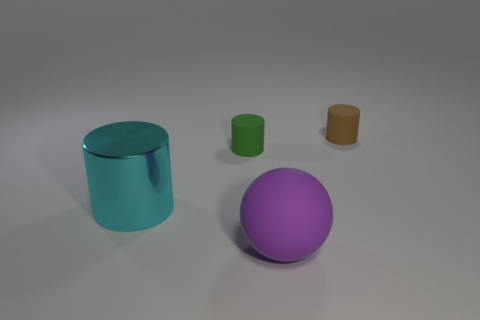Is the number of purple balls in front of the cyan cylinder greater than the number of tiny cyan metallic cubes?
Your response must be concise. Yes. What is the material of the thing that is to the right of the big cyan thing and left of the purple object?
Provide a succinct answer. Rubber. Is there any other thing that has the same shape as the small green thing?
Offer a very short reply. Yes. What number of objects are left of the small brown matte cylinder and on the right side of the cyan shiny cylinder?
Offer a terse response. 2. Are there an equal number of tiny green matte spheres and big purple rubber things?
Your answer should be compact. No. What is the large cylinder made of?
Your answer should be compact. Metal. Are there the same number of big purple matte spheres that are to the right of the small green rubber cylinder and big metal things?
Your answer should be very brief. Yes. How many other objects have the same shape as the tiny green matte object?
Provide a succinct answer. 2. Is the purple object the same shape as the brown thing?
Offer a terse response. No. How many things are either cylinders that are right of the tiny green cylinder or tiny purple matte balls?
Provide a succinct answer. 1. 